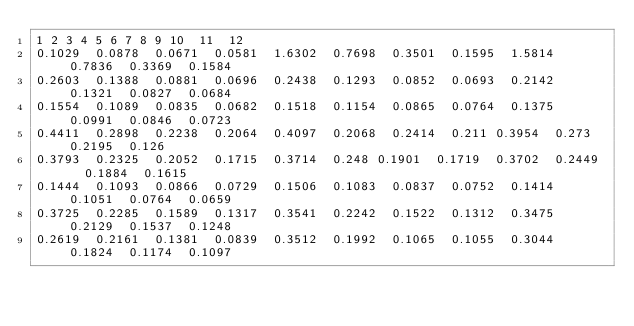Convert code to text. <code><loc_0><loc_0><loc_500><loc_500><_SQL_>1	2	3	4	5	6	7	8	9	10	11	12
0.1029	0.0878	0.0671	0.0581	1.6302	0.7698	0.3501	0.1595	1.5814	0.7836	0.3369	0.1584
0.2603	0.1388	0.0881	0.0696	0.2438	0.1293	0.0852	0.0693	0.2142	0.1321	0.0827	0.0684
0.1554	0.1089	0.0835	0.0682	0.1518	0.1154	0.0865	0.0764	0.1375	0.0991	0.0846	0.0723
0.4411	0.2898	0.2238	0.2064	0.4097	0.2068	0.2414	0.211	0.3954	0.273	0.2195	0.126
0.3793	0.2325	0.2052	0.1715	0.3714	0.248	0.1901	0.1719	0.3702	0.2449	0.1884	0.1615
0.1444	0.1093	0.0866	0.0729	0.1506	0.1083	0.0837	0.0752	0.1414	0.1051	0.0764	0.0659
0.3725	0.2285	0.1589	0.1317	0.3541	0.2242	0.1522	0.1312	0.3475	0.2129	0.1537	0.1248
0.2619	0.2161	0.1381	0.0839	0.3512	0.1992	0.1065	0.1055	0.3044	0.1824	0.1174	0.1097
</code> 